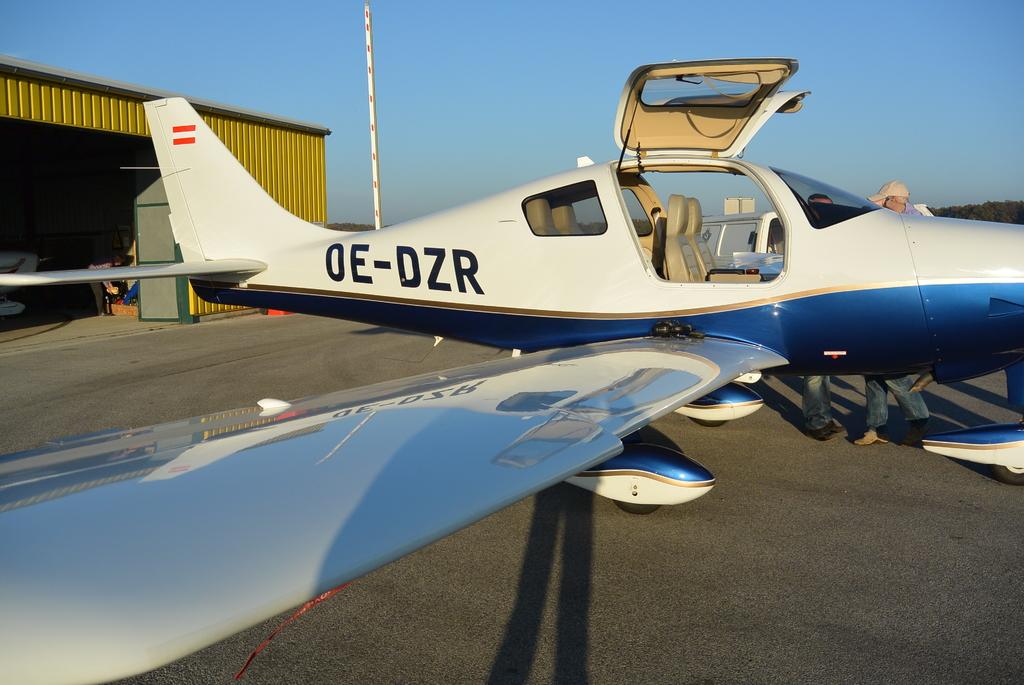What is the aircraft identification number?
Provide a succinct answer. Oe-dzr. How many people can fit in the plane?
Your response must be concise. 4. 